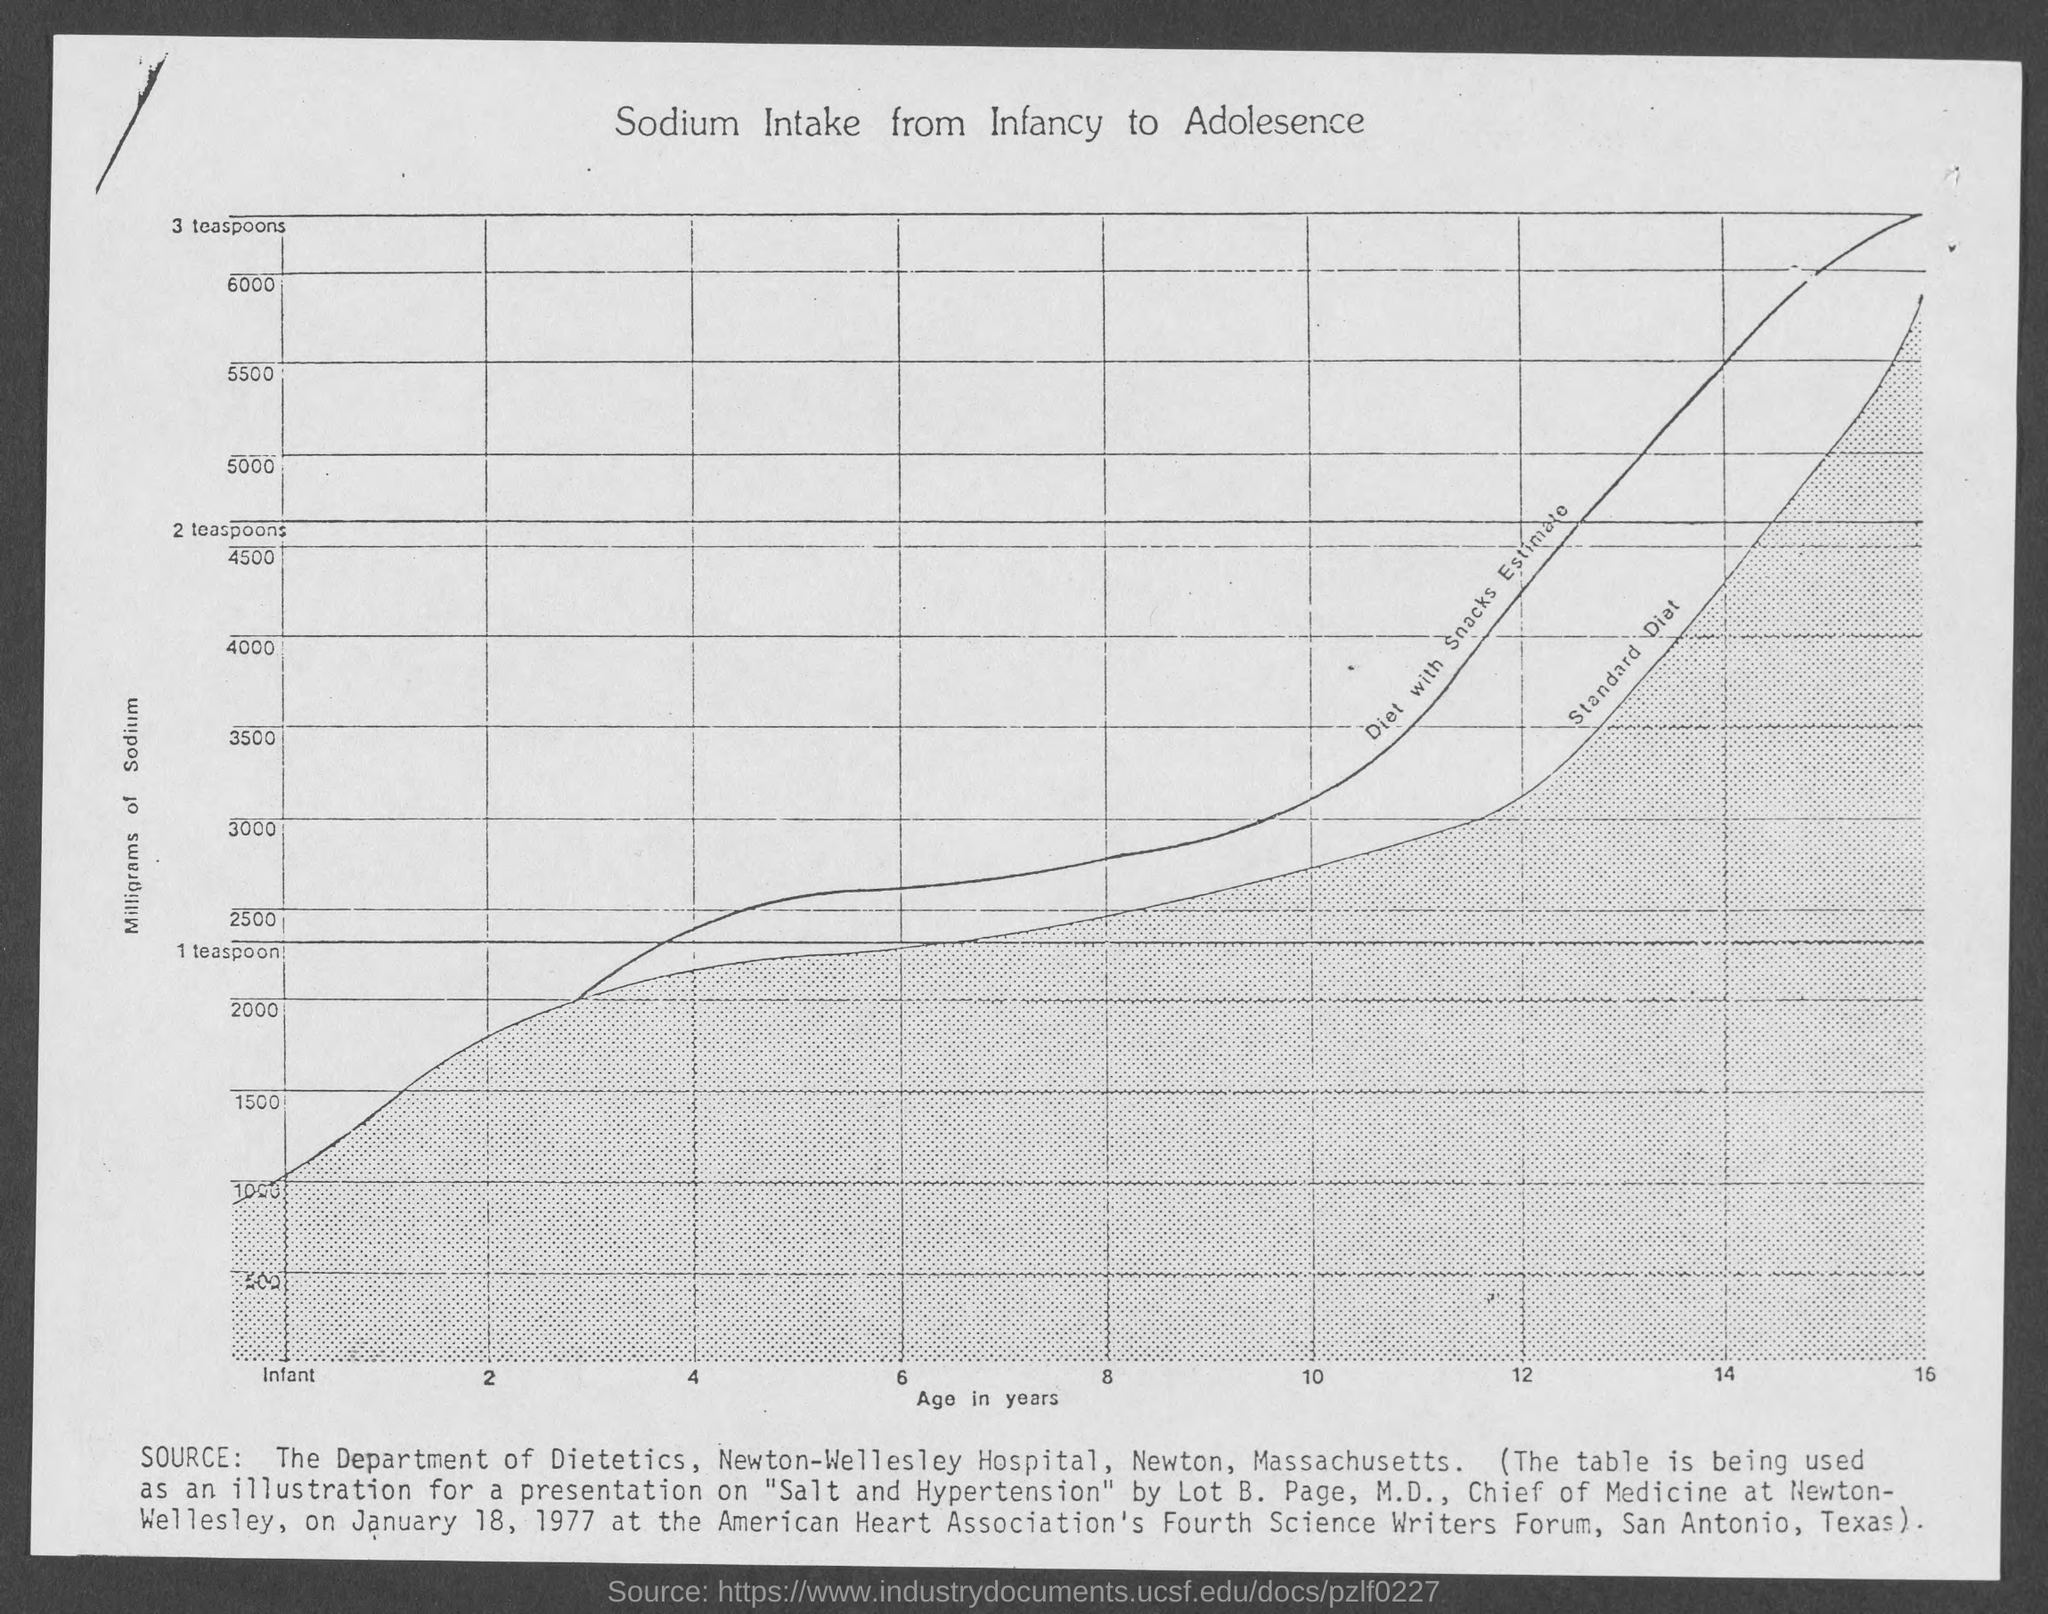What is the title of the graph?
Provide a short and direct response. Sodium intake from Infancy to Adolesence. 